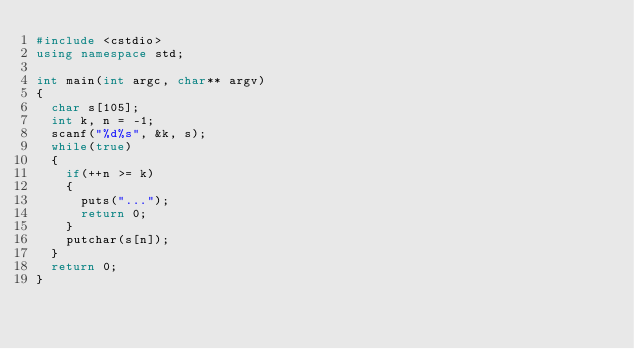<code> <loc_0><loc_0><loc_500><loc_500><_C++_>#include <cstdio>
using namespace std;

int main(int argc, char** argv)
{
	char s[105];
	int k, n = -1;
	scanf("%d%s", &k, s);
	while(true)
	{
		if(++n >= k)
		{
			puts("...");
			return 0;
		}
		putchar(s[n]);
	}
	return 0;
}</code> 